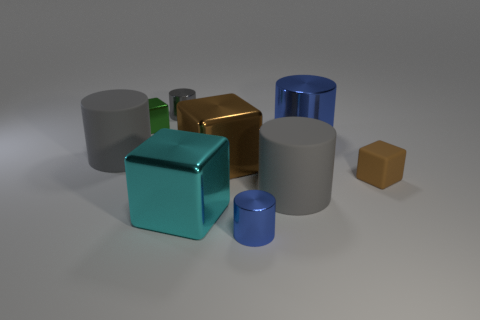How many gray cylinders must be subtracted to get 1 gray cylinders? 2 Subtract all yellow cubes. How many gray cylinders are left? 3 Subtract all big shiny cylinders. How many cylinders are left? 4 Subtract 1 cylinders. How many cylinders are left? 4 Subtract all yellow cylinders. Subtract all purple balls. How many cylinders are left? 5 Subtract all cylinders. How many objects are left? 4 Subtract 0 purple blocks. How many objects are left? 9 Subtract all gray metallic objects. Subtract all cyan blocks. How many objects are left? 7 Add 5 large blue metal cylinders. How many large blue metal cylinders are left? 6 Add 4 gray cylinders. How many gray cylinders exist? 7 